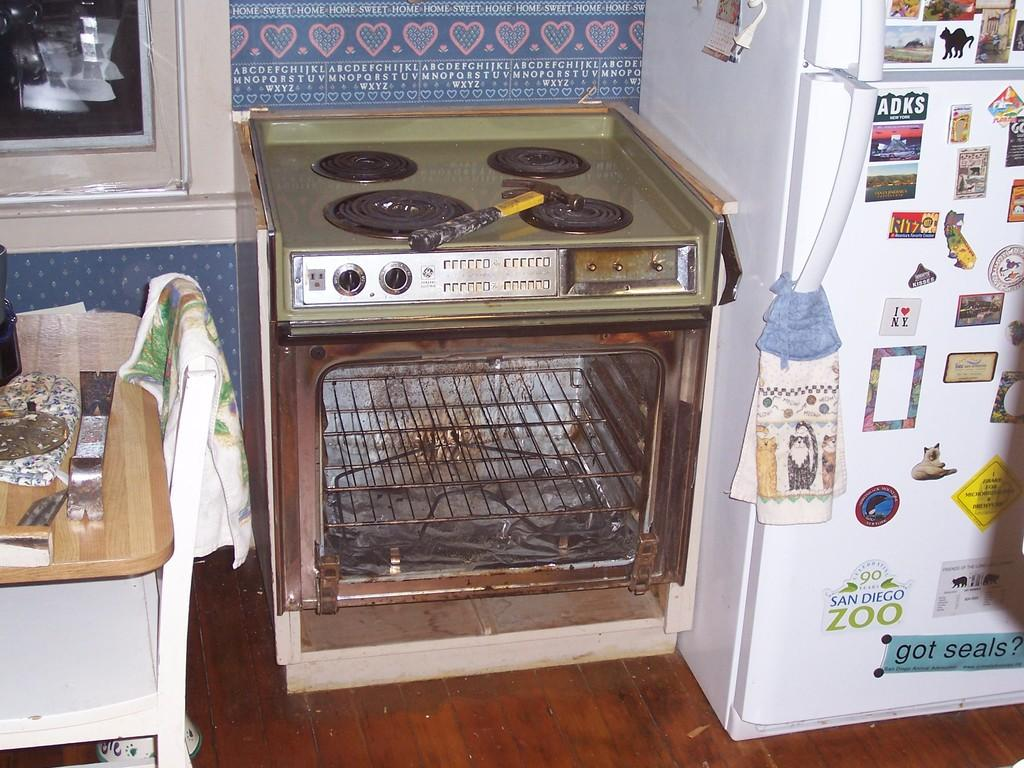<image>
Render a clear and concise summary of the photo. a rusty oven missing the door set against a wall with a border of hearts and the alphabet 